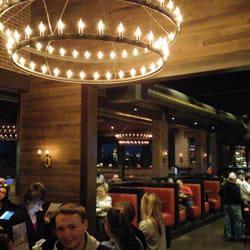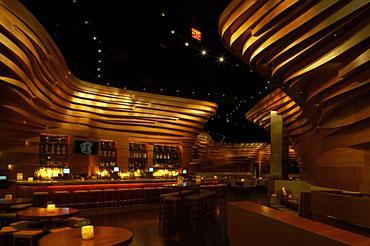The first image is the image on the left, the second image is the image on the right. Examine the images to the left and right. Is the description "The left image contains at least one chandelier." accurate? Answer yes or no. Yes. The first image is the image on the left, the second image is the image on the right. Analyze the images presented: Is the assertion "The left image shows an interior with lights in a circle suspended from the ceiling, and the right image shows an interior with sculpted curving walls facing rows of seats." valid? Answer yes or no. Yes. 